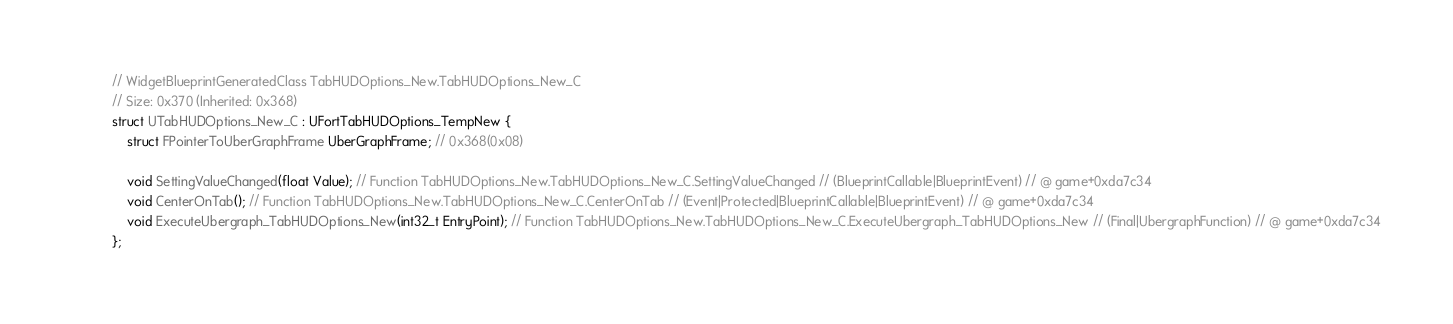<code> <loc_0><loc_0><loc_500><loc_500><_C_>// WidgetBlueprintGeneratedClass TabHUDOptions_New.TabHUDOptions_New_C
// Size: 0x370 (Inherited: 0x368)
struct UTabHUDOptions_New_C : UFortTabHUDOptions_TempNew {
	struct FPointerToUberGraphFrame UberGraphFrame; // 0x368(0x08)

	void SettingValueChanged(float Value); // Function TabHUDOptions_New.TabHUDOptions_New_C.SettingValueChanged // (BlueprintCallable|BlueprintEvent) // @ game+0xda7c34
	void CenterOnTab(); // Function TabHUDOptions_New.TabHUDOptions_New_C.CenterOnTab // (Event|Protected|BlueprintCallable|BlueprintEvent) // @ game+0xda7c34
	void ExecuteUbergraph_TabHUDOptions_New(int32_t EntryPoint); // Function TabHUDOptions_New.TabHUDOptions_New_C.ExecuteUbergraph_TabHUDOptions_New // (Final|UbergraphFunction) // @ game+0xda7c34
};

</code> 